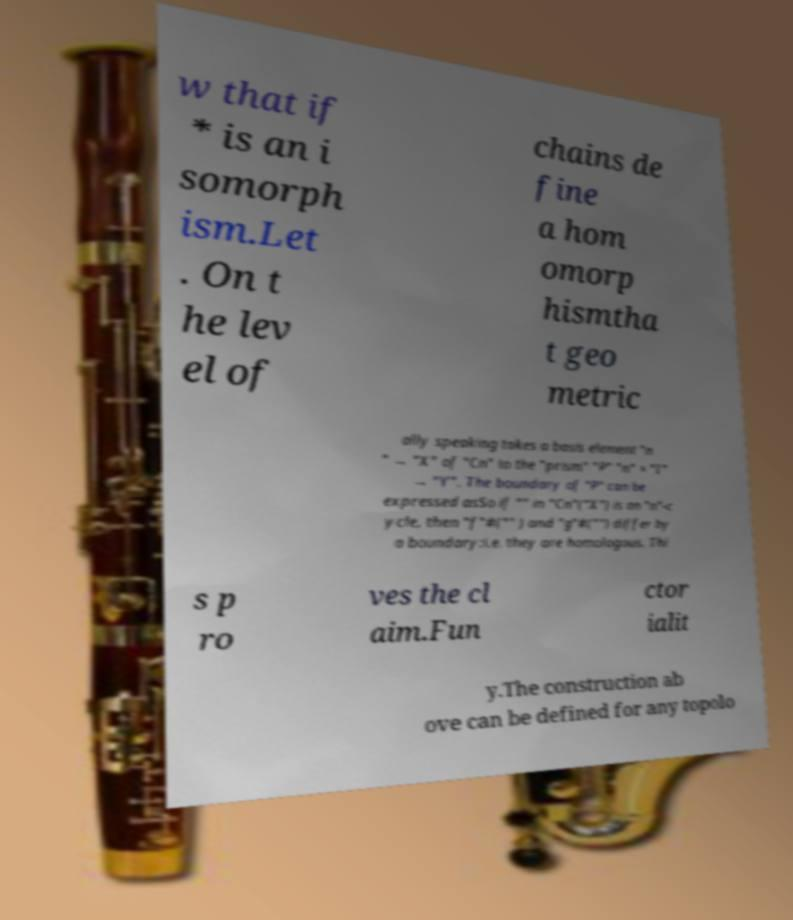There's text embedded in this image that I need extracted. Can you transcribe it verbatim? w that if * is an i somorph ism.Let . On t he lev el of chains de fine a hom omorp hismtha t geo metric ally speaking takes a basis element "n " → "X" of "Cn" to the "prism" "P" "n" × "I" → "Y". The boundary of "P" can be expressed asSo if "" in "Cn"("X") is an "n"-c ycle, then "f"#("" ) and "g"#("") differ by a boundary:i.e. they are homologous. Thi s p ro ves the cl aim.Fun ctor ialit y.The construction ab ove can be defined for any topolo 